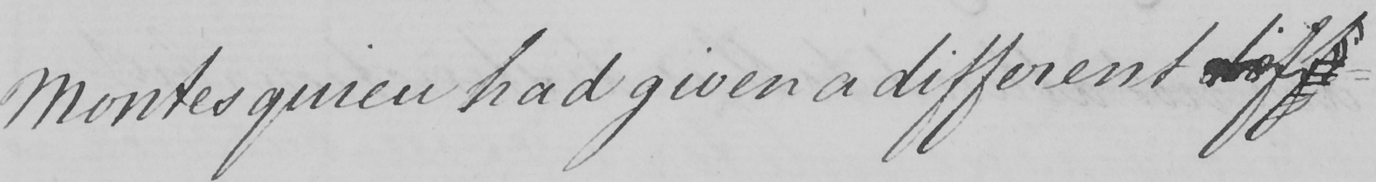Please transcribe the handwritten text in this image. Montesquieu had given a different diff 